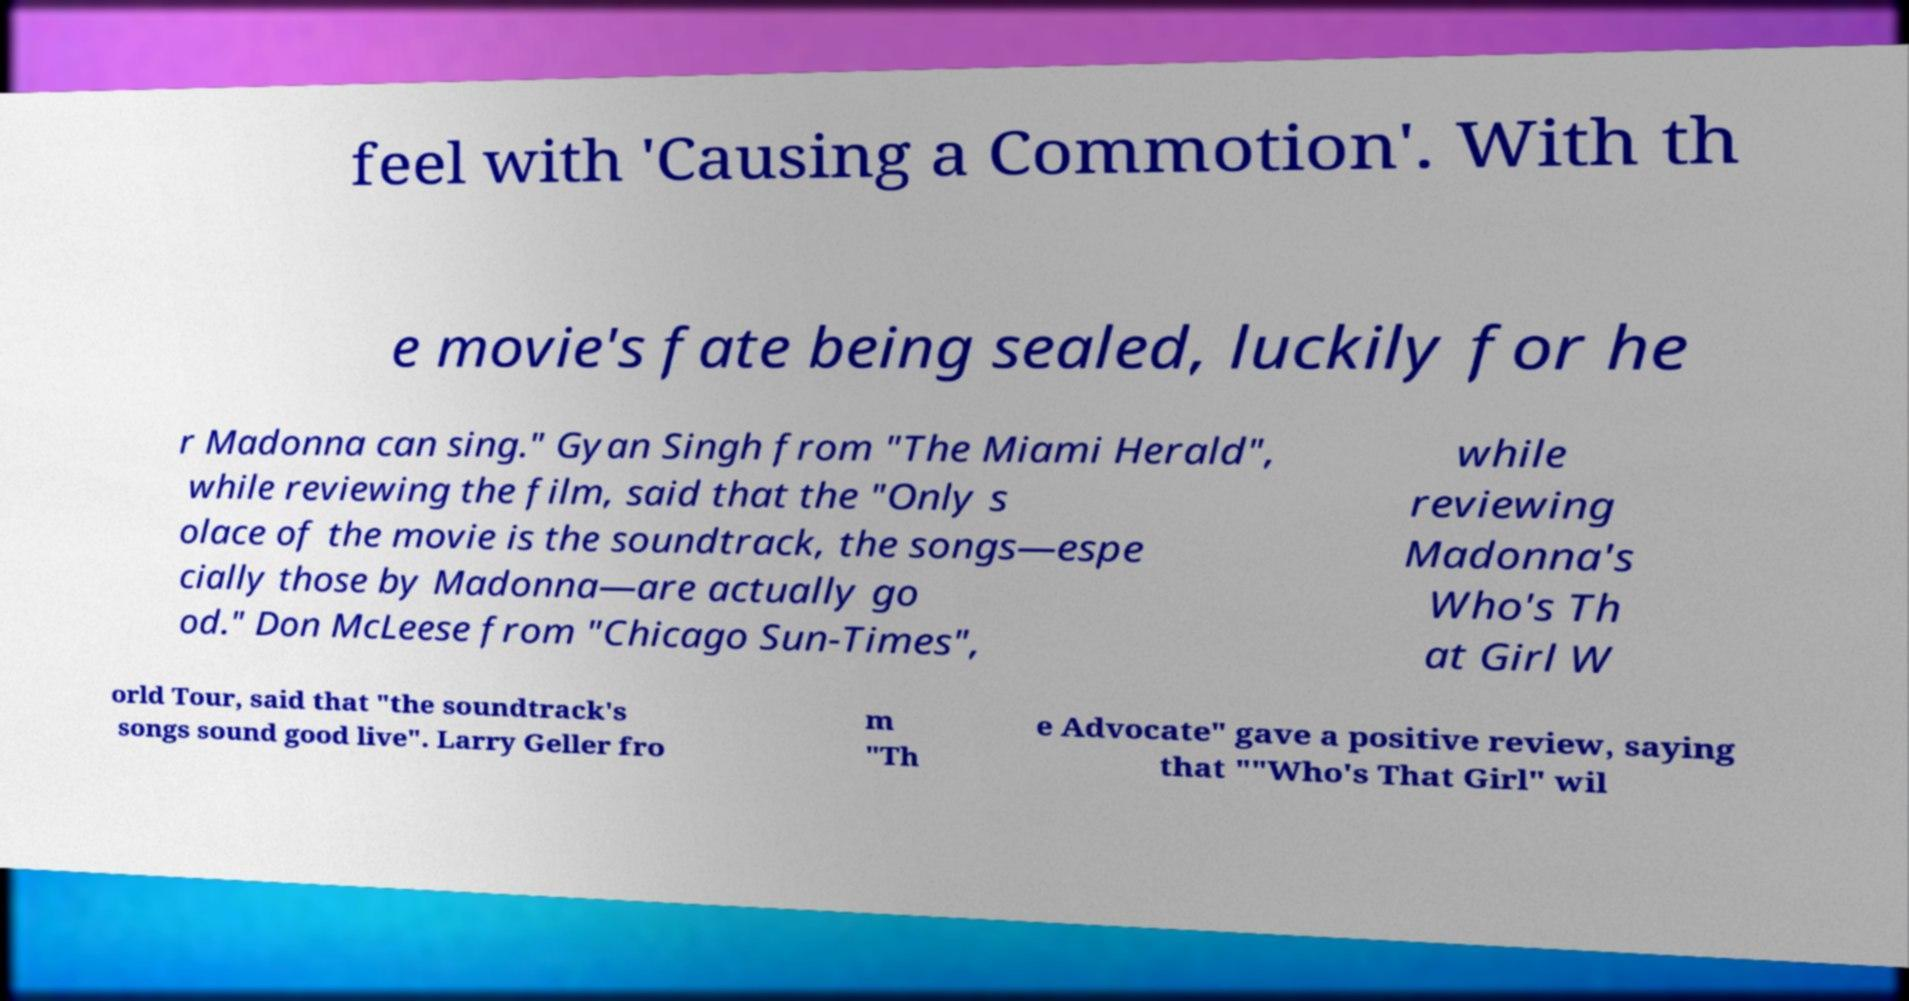What messages or text are displayed in this image? I need them in a readable, typed format. feel with 'Causing a Commotion'. With th e movie's fate being sealed, luckily for he r Madonna can sing." Gyan Singh from "The Miami Herald", while reviewing the film, said that the "Only s olace of the movie is the soundtrack, the songs—espe cially those by Madonna—are actually go od." Don McLeese from "Chicago Sun-Times", while reviewing Madonna's Who's Th at Girl W orld Tour, said that "the soundtrack's songs sound good live". Larry Geller fro m "Th e Advocate" gave a positive review, saying that ""Who's That Girl" wil 